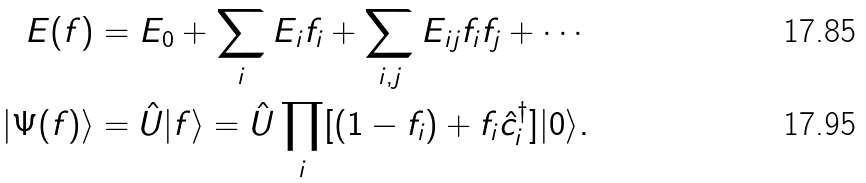<formula> <loc_0><loc_0><loc_500><loc_500>E ( f ) & = E _ { 0 } + \sum _ { i } E _ { i } f _ { i } + \sum _ { i , j } E _ { i j } f _ { i } f _ { j } + \cdots \\ | \Psi ( f ) \rangle & = \hat { U } | f \rangle = \hat { U } \prod _ { i } [ ( 1 - f _ { i } ) + f _ { i } \hat { c } _ { i } ^ { \dag } ] | 0 \rangle .</formula> 